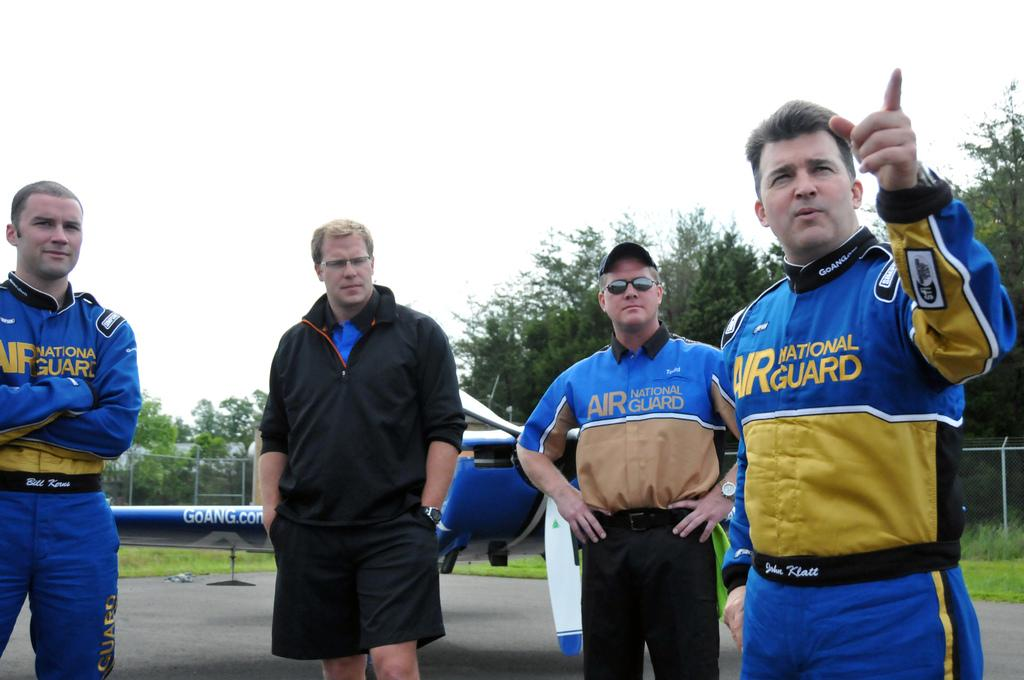<image>
Render a clear and concise summary of the photo. people in yellow and blue Air National Guard uniforms 